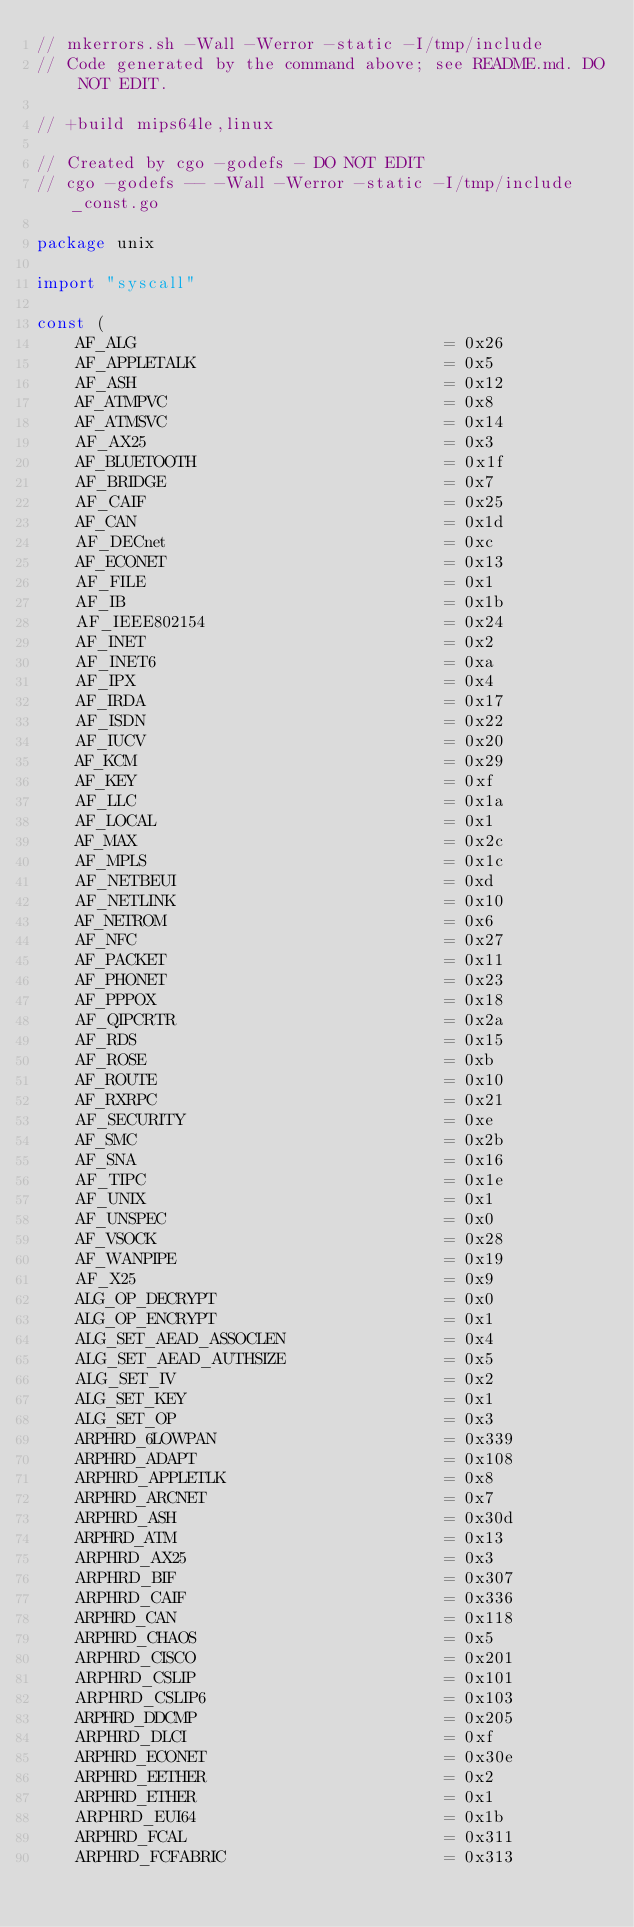<code> <loc_0><loc_0><loc_500><loc_500><_Go_>// mkerrors.sh -Wall -Werror -static -I/tmp/include
// Code generated by the command above; see README.md. DO NOT EDIT.

// +build mips64le,linux

// Created by cgo -godefs - DO NOT EDIT
// cgo -godefs -- -Wall -Werror -static -I/tmp/include _const.go

package unix

import "syscall"

const (
	AF_ALG                               = 0x26
	AF_APPLETALK                         = 0x5
	AF_ASH                               = 0x12
	AF_ATMPVC                            = 0x8
	AF_ATMSVC                            = 0x14
	AF_AX25                              = 0x3
	AF_BLUETOOTH                         = 0x1f
	AF_BRIDGE                            = 0x7
	AF_CAIF                              = 0x25
	AF_CAN                               = 0x1d
	AF_DECnet                            = 0xc
	AF_ECONET                            = 0x13
	AF_FILE                              = 0x1
	AF_IB                                = 0x1b
	AF_IEEE802154                        = 0x24
	AF_INET                              = 0x2
	AF_INET6                             = 0xa
	AF_IPX                               = 0x4
	AF_IRDA                              = 0x17
	AF_ISDN                              = 0x22
	AF_IUCV                              = 0x20
	AF_KCM                               = 0x29
	AF_KEY                               = 0xf
	AF_LLC                               = 0x1a
	AF_LOCAL                             = 0x1
	AF_MAX                               = 0x2c
	AF_MPLS                              = 0x1c
	AF_NETBEUI                           = 0xd
	AF_NETLINK                           = 0x10
	AF_NETROM                            = 0x6
	AF_NFC                               = 0x27
	AF_PACKET                            = 0x11
	AF_PHONET                            = 0x23
	AF_PPPOX                             = 0x18
	AF_QIPCRTR                           = 0x2a
	AF_RDS                               = 0x15
	AF_ROSE                              = 0xb
	AF_ROUTE                             = 0x10
	AF_RXRPC                             = 0x21
	AF_SECURITY                          = 0xe
	AF_SMC                               = 0x2b
	AF_SNA                               = 0x16
	AF_TIPC                              = 0x1e
	AF_UNIX                              = 0x1
	AF_UNSPEC                            = 0x0
	AF_VSOCK                             = 0x28
	AF_WANPIPE                           = 0x19
	AF_X25                               = 0x9
	ALG_OP_DECRYPT                       = 0x0
	ALG_OP_ENCRYPT                       = 0x1
	ALG_SET_AEAD_ASSOCLEN                = 0x4
	ALG_SET_AEAD_AUTHSIZE                = 0x5
	ALG_SET_IV                           = 0x2
	ALG_SET_KEY                          = 0x1
	ALG_SET_OP                           = 0x3
	ARPHRD_6LOWPAN                       = 0x339
	ARPHRD_ADAPT                         = 0x108
	ARPHRD_APPLETLK                      = 0x8
	ARPHRD_ARCNET                        = 0x7
	ARPHRD_ASH                           = 0x30d
	ARPHRD_ATM                           = 0x13
	ARPHRD_AX25                          = 0x3
	ARPHRD_BIF                           = 0x307
	ARPHRD_CAIF                          = 0x336
	ARPHRD_CAN                           = 0x118
	ARPHRD_CHAOS                         = 0x5
	ARPHRD_CISCO                         = 0x201
	ARPHRD_CSLIP                         = 0x101
	ARPHRD_CSLIP6                        = 0x103
	ARPHRD_DDCMP                         = 0x205
	ARPHRD_DLCI                          = 0xf
	ARPHRD_ECONET                        = 0x30e
	ARPHRD_EETHER                        = 0x2
	ARPHRD_ETHER                         = 0x1
	ARPHRD_EUI64                         = 0x1b
	ARPHRD_FCAL                          = 0x311
	ARPHRD_FCFABRIC                      = 0x313</code> 